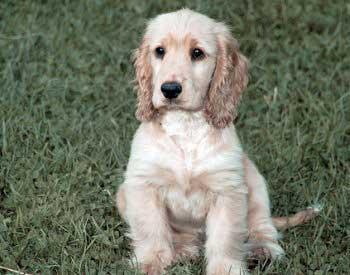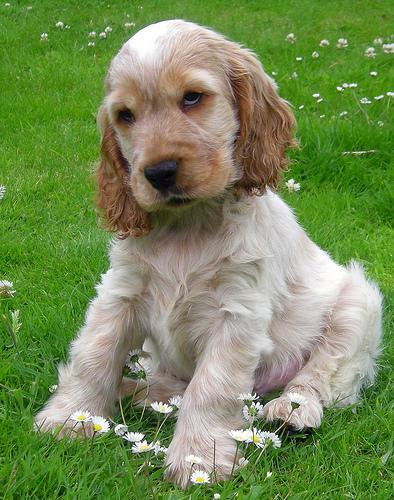The first image is the image on the left, the second image is the image on the right. Considering the images on both sides, is "The dog in the image on the right is sitting on green grass." valid? Answer yes or no. Yes. 